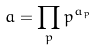Convert formula to latex. <formula><loc_0><loc_0><loc_500><loc_500>a = \prod _ { p } p ^ { a _ { p } }</formula> 